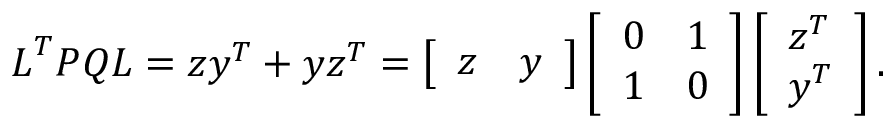Convert formula to latex. <formula><loc_0><loc_0><loc_500><loc_500>L ^ { T } P Q L = z y ^ { T } + y z ^ { T } = \left [ \begin{array} { l l } { z } & { y } \end{array} \right ] \left [ \begin{array} { l l } { 0 } & { 1 } \\ { 1 } & { 0 } \end{array} \right ] \left [ \begin{array} { l } { z ^ { T } } \\ { y ^ { T } } \end{array} \right ] .</formula> 